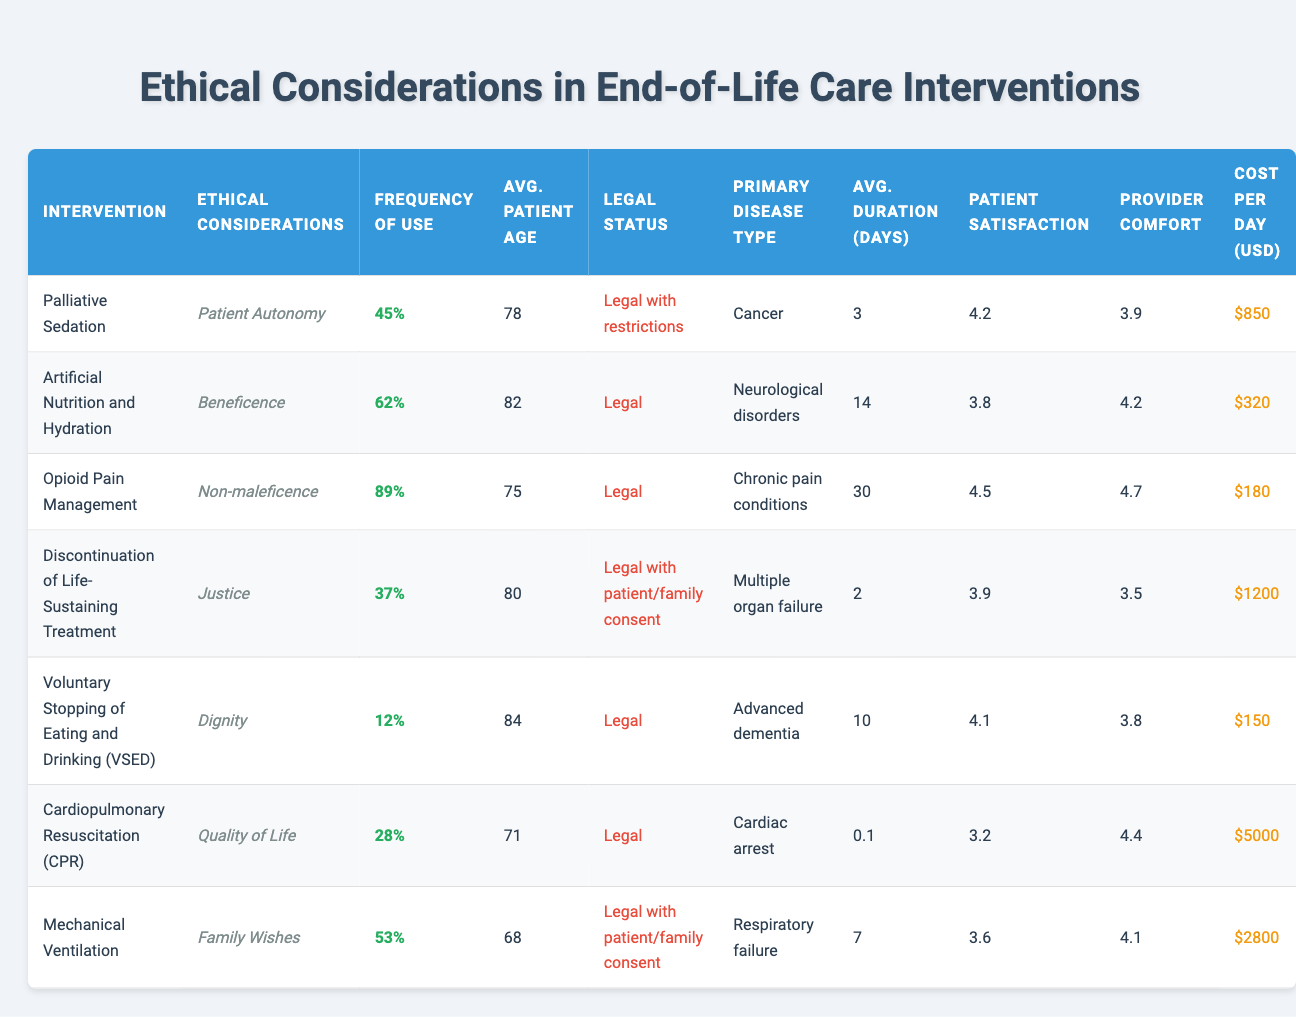What is the frequency of use for Palliative Sedation? According to the table, the frequency of use for Palliative Sedation is listed as 45%.
Answer: 45% Which intervention has the highest patient satisfaction score? The table shows the patient satisfaction scores for each intervention. Opioid Pain Management has the highest score of 4.5.
Answer: 4.5 Is Artificial Nutrition and Hydration legal? The legal status for Artificial Nutrition and Hydration in the table is labeled as "Legal."
Answer: Yes What is the average patient age for Voluntary Stopping of Eating and Drinking (VSED)? The average patient age for VSED is given in the table as 84 years.
Answer: 84 Which intervention is most frequently used in end-of-life care? By comparing the frequency of use percentages, Opioid Pain Management at 89% is the highest.
Answer: 89% What is the average cost per day for Cardiopulmonary Resuscitation (CPR)? The table indicates that the cost per day for CPR is $5000.
Answer: $5000 Which two interventions have the legal status of "Legal with patient/family consent"? Referring to the legal status column, the interventions Discontinuation of Life-Sustaining Treatment and Mechanical Ventilation are both labeled as "Legal with patient/family consent."
Answer: Discontinuation of Life-Sustaining Treatment and Mechanical Ventilation What is the average duration in days for Palliative Sedation compared to Opioid Pain Management? The average duration for Palliative Sedation is 3 days and for Opioid Pain Management is 30 days. The difference is 30 - 3 = 27 days.
Answer: 27 days Calculate the average patient age across all interventions. To find the average, sum the patient ages (78 + 82 + 75 + 80 + 84 + 71 + 68 = 538) and divide by the number of interventions (7). The average is 538 / 7 = 76.86 which is approximately 77.
Answer: 77 Which intervention has the lowest frequency of use? From the frequency of use column, Voluntary Stopping of Eating and Drinking (VSED) has the lowest frequency at 12%.
Answer: 12% How does the healthcare provider comfort level for Mechanical Ventilation compare to that of Palliative Sedation? Mechanical Ventilation has a comfort level of 4.1 while Palliative Sedation has 3.9. The difference is 4.1 - 3.9 = 0.2, indicating a higher comfort level for Mechanical Ventilation.
Answer: 0.2 